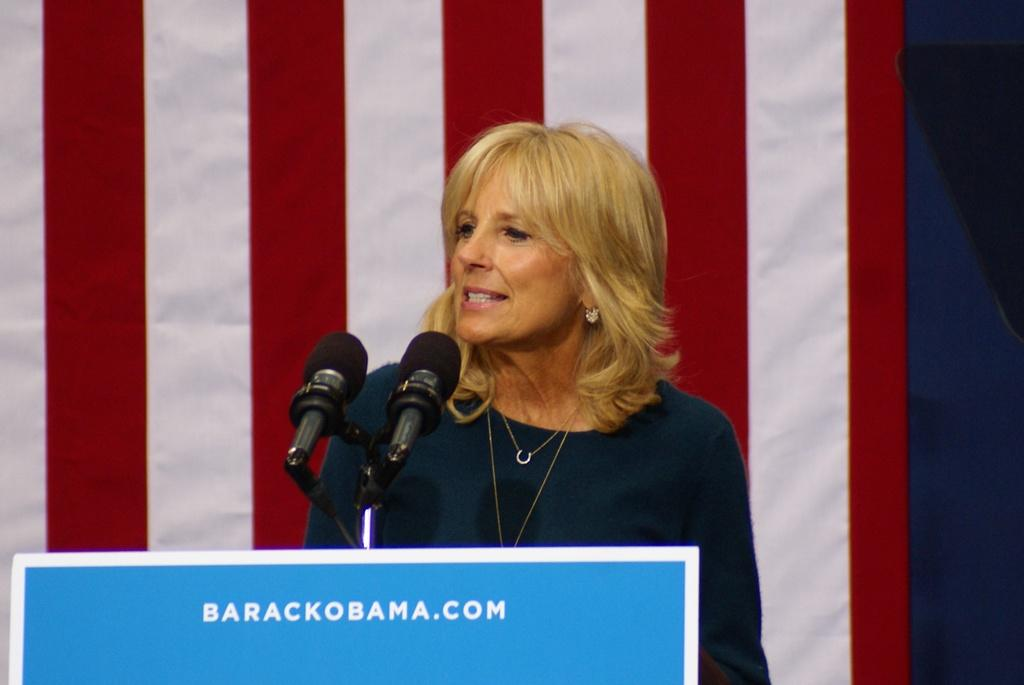Who is the main subject in the image? There is a woman in the image. What is the woman doing in the image? The woman is standing at a podium and speaking. What objects are present to aid the woman in her speech? Microphones are present in the image. What can be seen in the background of the image? There is a flag in the background of the image. What is written on the podium? There is text on the podium. What type of tail can be seen on the woman in the image? There is no tail present on the woman in the image. What experience does the woman have in public speaking? The image does not provide any information about the woman's experience in public speaking. 